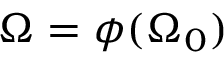Convert formula to latex. <formula><loc_0><loc_0><loc_500><loc_500>\Omega = \phi ( \Omega _ { 0 } )</formula> 